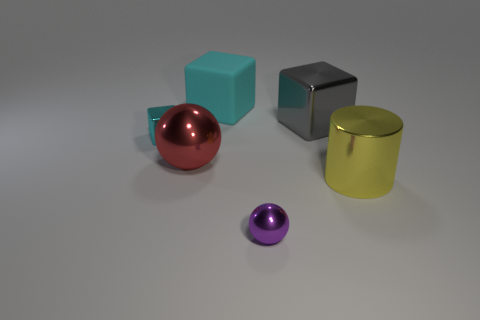Add 2 things. How many objects exist? 8 Subtract all cylinders. How many objects are left? 5 Subtract 0 brown cubes. How many objects are left? 6 Subtract all large spheres. Subtract all big cylinders. How many objects are left? 4 Add 2 yellow things. How many yellow things are left? 3 Add 5 tiny balls. How many tiny balls exist? 6 